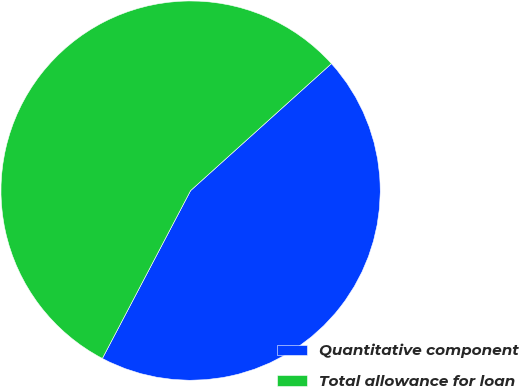<chart> <loc_0><loc_0><loc_500><loc_500><pie_chart><fcel>Quantitative component<fcel>Total allowance for loan<nl><fcel>44.38%<fcel>55.62%<nl></chart> 